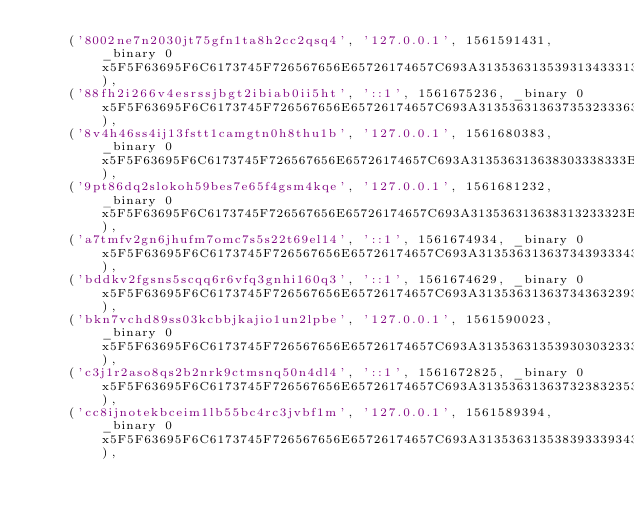<code> <loc_0><loc_0><loc_500><loc_500><_SQL_>	('8002ne7n2030jt75gfn1ta8h2cc2qsq4', '127.0.0.1', 1561591431, _binary 0x5F5F63695F6C6173745F726567656E65726174657C693A313536313539313433313B),
	('88fh2i266v4esrssjbgt2ibiab0ii5ht', '::1', 1561675236, _binary 0x5F5F63695F6C6173745F726567656E65726174657C693A313536313637353233363B),
	('8v4h46ss4ij13fstt1camgtn0h8thu1b', '127.0.0.1', 1561680383, _binary 0x5F5F63695F6C6173745F726567656E65726174657C693A313536313638303338333B696441646D696E7C733A313A2231223B656D61696C7C733A33333A2266656C6970652E6B6F73736D616E6E40616C756E6F2E73632E73656E61632E6272223B6C6F6761646F7C623A313B),
	('9pt86dq2slokoh59bes7e65f4gsm4kqe', '127.0.0.1', 1561681232, _binary 0x5F5F63695F6C6173745F726567656E65726174657C693A313536313638313233323B696441646D696E7C733A313A2231223B656D61696C7C733A33333A2266656C6970652E6B6F73736D616E6E40616C756E6F2E73632E73656E61632E6272223B6C6F6761646F7C623A313B),
	('a7tmfv2gn6jhufm7omc7s5s22t69el14', '::1', 1561674934, _binary 0x5F5F63695F6C6173745F726567656E65726174657C693A313536313637343933343B),
	('bddkv2fgsns5scqq6r6vfq3gnhi160q3', '::1', 1561674629, _binary 0x5F5F63695F6C6173745F726567656E65726174657C693A313536313637343632393B),
	('bkn7vchd89ss03kcbbjkajio1un2lpbe', '127.0.0.1', 1561590023, _binary 0x5F5F63695F6C6173745F726567656E65726174657C693A313536313539303032333B),
	('c3j1r2aso8qs2b2nrk9ctmsnq50n4dl4', '::1', 1561672825, _binary 0x5F5F63695F6C6173745F726567656E65726174657C693A313536313637323832353B),
	('cc8ijnotekbceim1lb55bc4rc3jvbf1m', '127.0.0.1', 1561589394, _binary 0x5F5F63695F6C6173745F726567656E65726174657C693A313536313538393339343B),</code> 